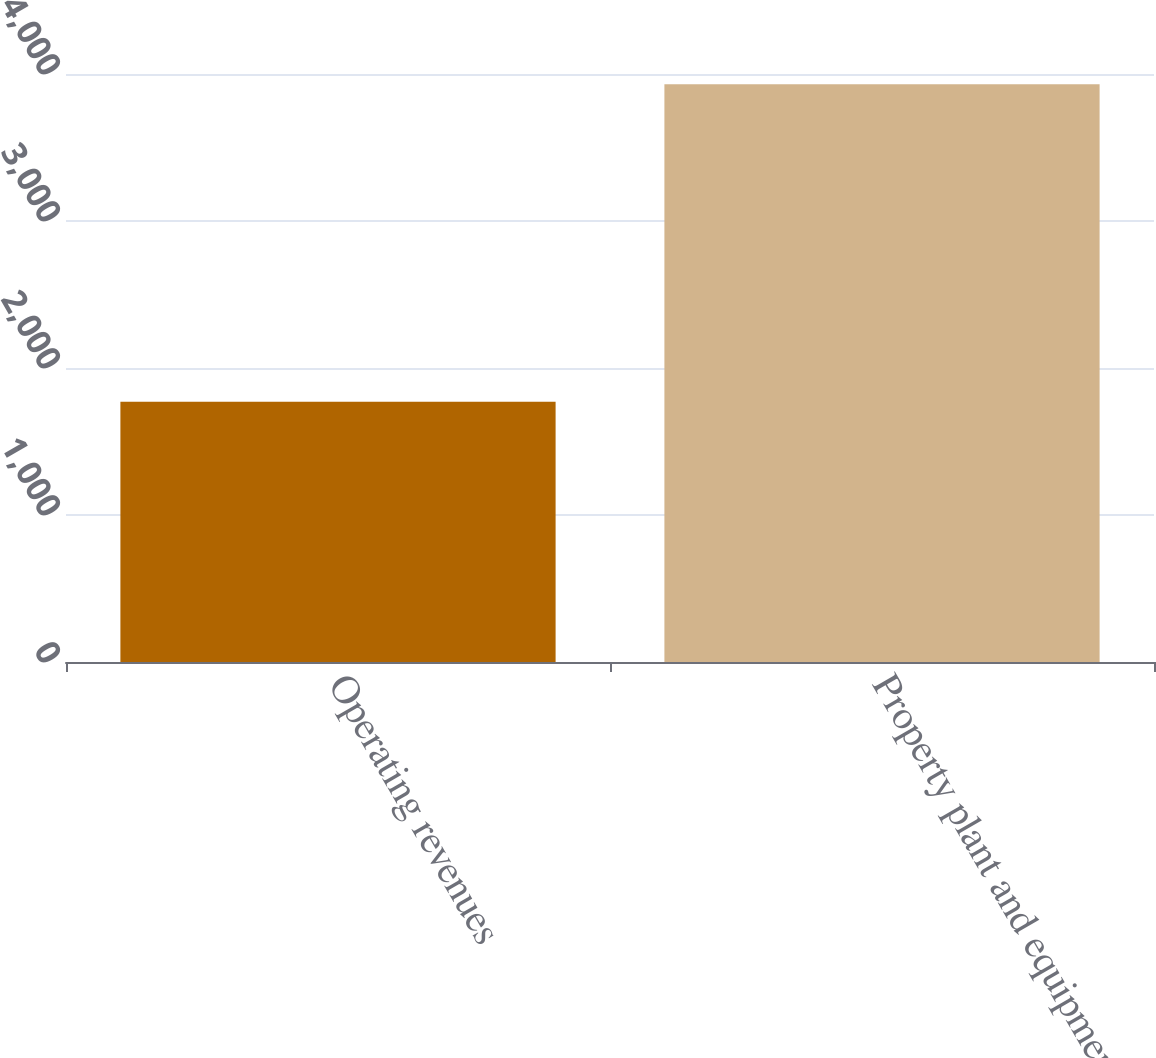<chart> <loc_0><loc_0><loc_500><loc_500><bar_chart><fcel>Operating revenues<fcel>Property plant and equipment<nl><fcel>1771<fcel>3930<nl></chart> 